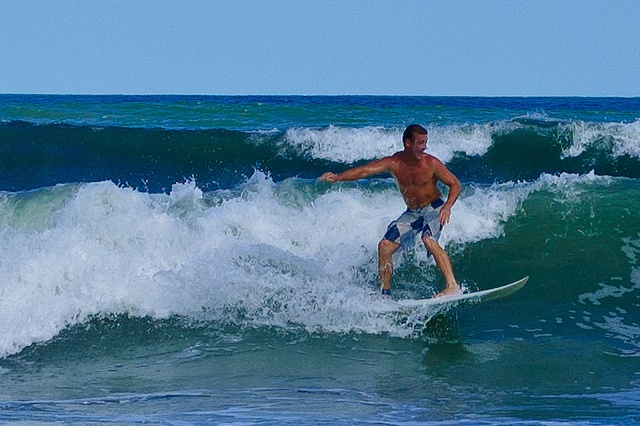Describe the objects in this image and their specific colors. I can see people in lightblue, maroon, black, brown, and gray tones and surfboard in lightblue, darkgray, teal, and gray tones in this image. 